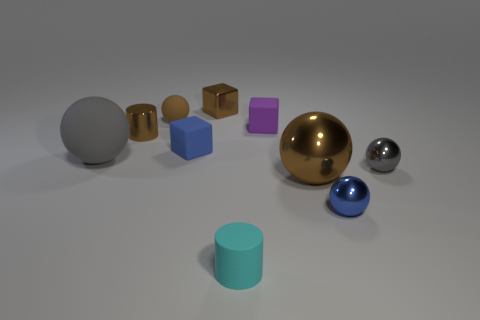What is the shape of the small brown object that is the same material as the brown cube?
Your answer should be very brief. Cylinder. What is the color of the tiny rubber thing to the right of the cylinder in front of the shiny sphere that is behind the big metallic object?
Your response must be concise. Purple. Is the number of small gray metal things that are on the right side of the small gray metallic thing the same as the number of big yellow metal cubes?
Your response must be concise. Yes. Does the metallic cylinder have the same color as the small cube that is behind the brown rubber sphere?
Your response must be concise. Yes. Is there a brown sphere that is left of the cylinder that is to the right of the shiny cube that is right of the blue rubber cube?
Your answer should be compact. Yes. Is the number of balls to the left of the small purple matte block less than the number of metal things?
Provide a short and direct response. Yes. How many other things are there of the same shape as the purple object?
Make the answer very short. 2. How many objects are small blue things that are in front of the gray rubber sphere or tiny blue metal objects in front of the small brown rubber ball?
Offer a terse response. 1. There is a brown metallic object that is in front of the purple object and to the right of the blue cube; what size is it?
Offer a terse response. Large. There is a tiny brown thing to the left of the small rubber ball; is it the same shape as the large rubber thing?
Your answer should be very brief. No. 